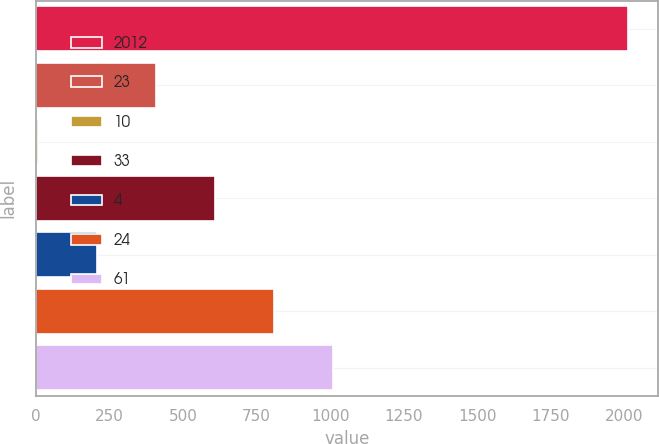Convert chart. <chart><loc_0><loc_0><loc_500><loc_500><bar_chart><fcel>2012<fcel>23<fcel>10<fcel>33<fcel>4<fcel>24<fcel>61<nl><fcel>2012<fcel>408.8<fcel>8<fcel>609.2<fcel>208.4<fcel>809.6<fcel>1010<nl></chart> 